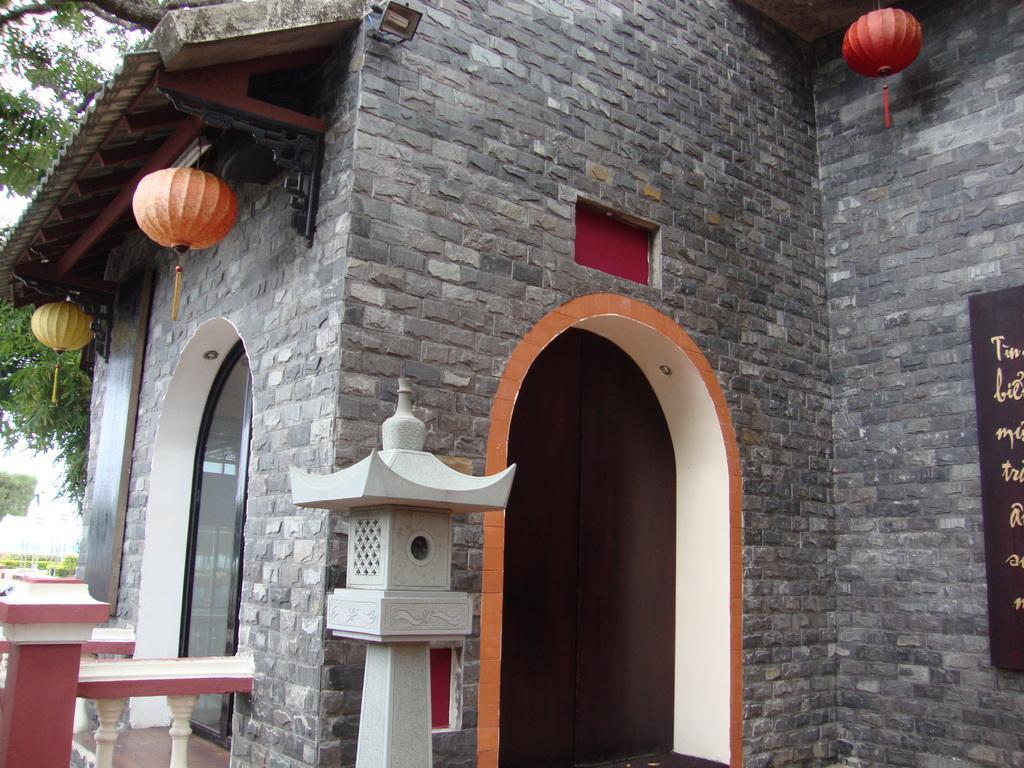Could you give a brief overview of what you see in this image? In this image in the center there is a building and on the right side there is a board with some text written on the board. On the top there are lanterns hanging. In the front there is a stand which is white in colour. On the left side there is glass on the wall and there are trees. 